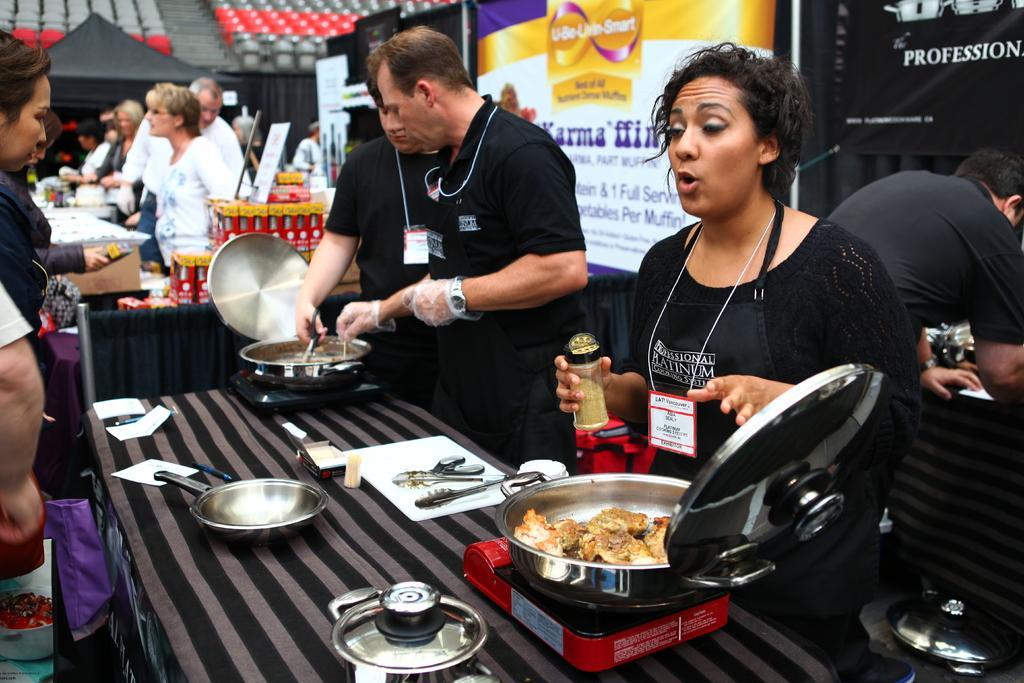In one or two sentences, can you explain what this image depicts? In the foreground of the pictures there is a table, on the table there are pans, electric stoves and people. In the background there are people, banners, tables and other objects. At the top there are chairs and a tent. 